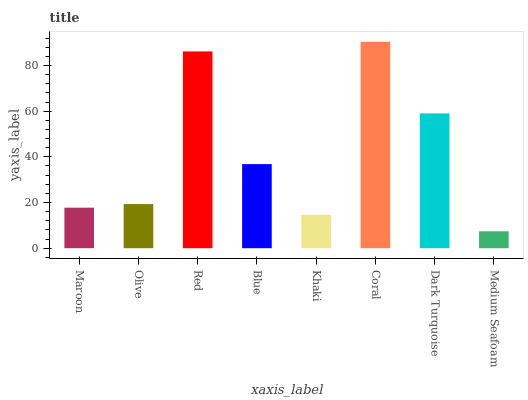Is Medium Seafoam the minimum?
Answer yes or no. Yes. Is Coral the maximum?
Answer yes or no. Yes. Is Olive the minimum?
Answer yes or no. No. Is Olive the maximum?
Answer yes or no. No. Is Olive greater than Maroon?
Answer yes or no. Yes. Is Maroon less than Olive?
Answer yes or no. Yes. Is Maroon greater than Olive?
Answer yes or no. No. Is Olive less than Maroon?
Answer yes or no. No. Is Blue the high median?
Answer yes or no. Yes. Is Olive the low median?
Answer yes or no. Yes. Is Medium Seafoam the high median?
Answer yes or no. No. Is Khaki the low median?
Answer yes or no. No. 